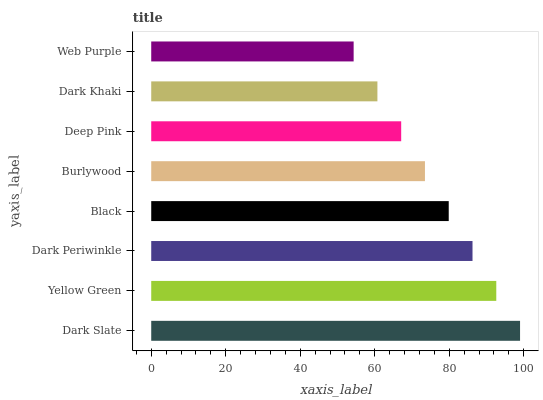Is Web Purple the minimum?
Answer yes or no. Yes. Is Dark Slate the maximum?
Answer yes or no. Yes. Is Yellow Green the minimum?
Answer yes or no. No. Is Yellow Green the maximum?
Answer yes or no. No. Is Dark Slate greater than Yellow Green?
Answer yes or no. Yes. Is Yellow Green less than Dark Slate?
Answer yes or no. Yes. Is Yellow Green greater than Dark Slate?
Answer yes or no. No. Is Dark Slate less than Yellow Green?
Answer yes or no. No. Is Black the high median?
Answer yes or no. Yes. Is Burlywood the low median?
Answer yes or no. Yes. Is Yellow Green the high median?
Answer yes or no. No. Is Yellow Green the low median?
Answer yes or no. No. 